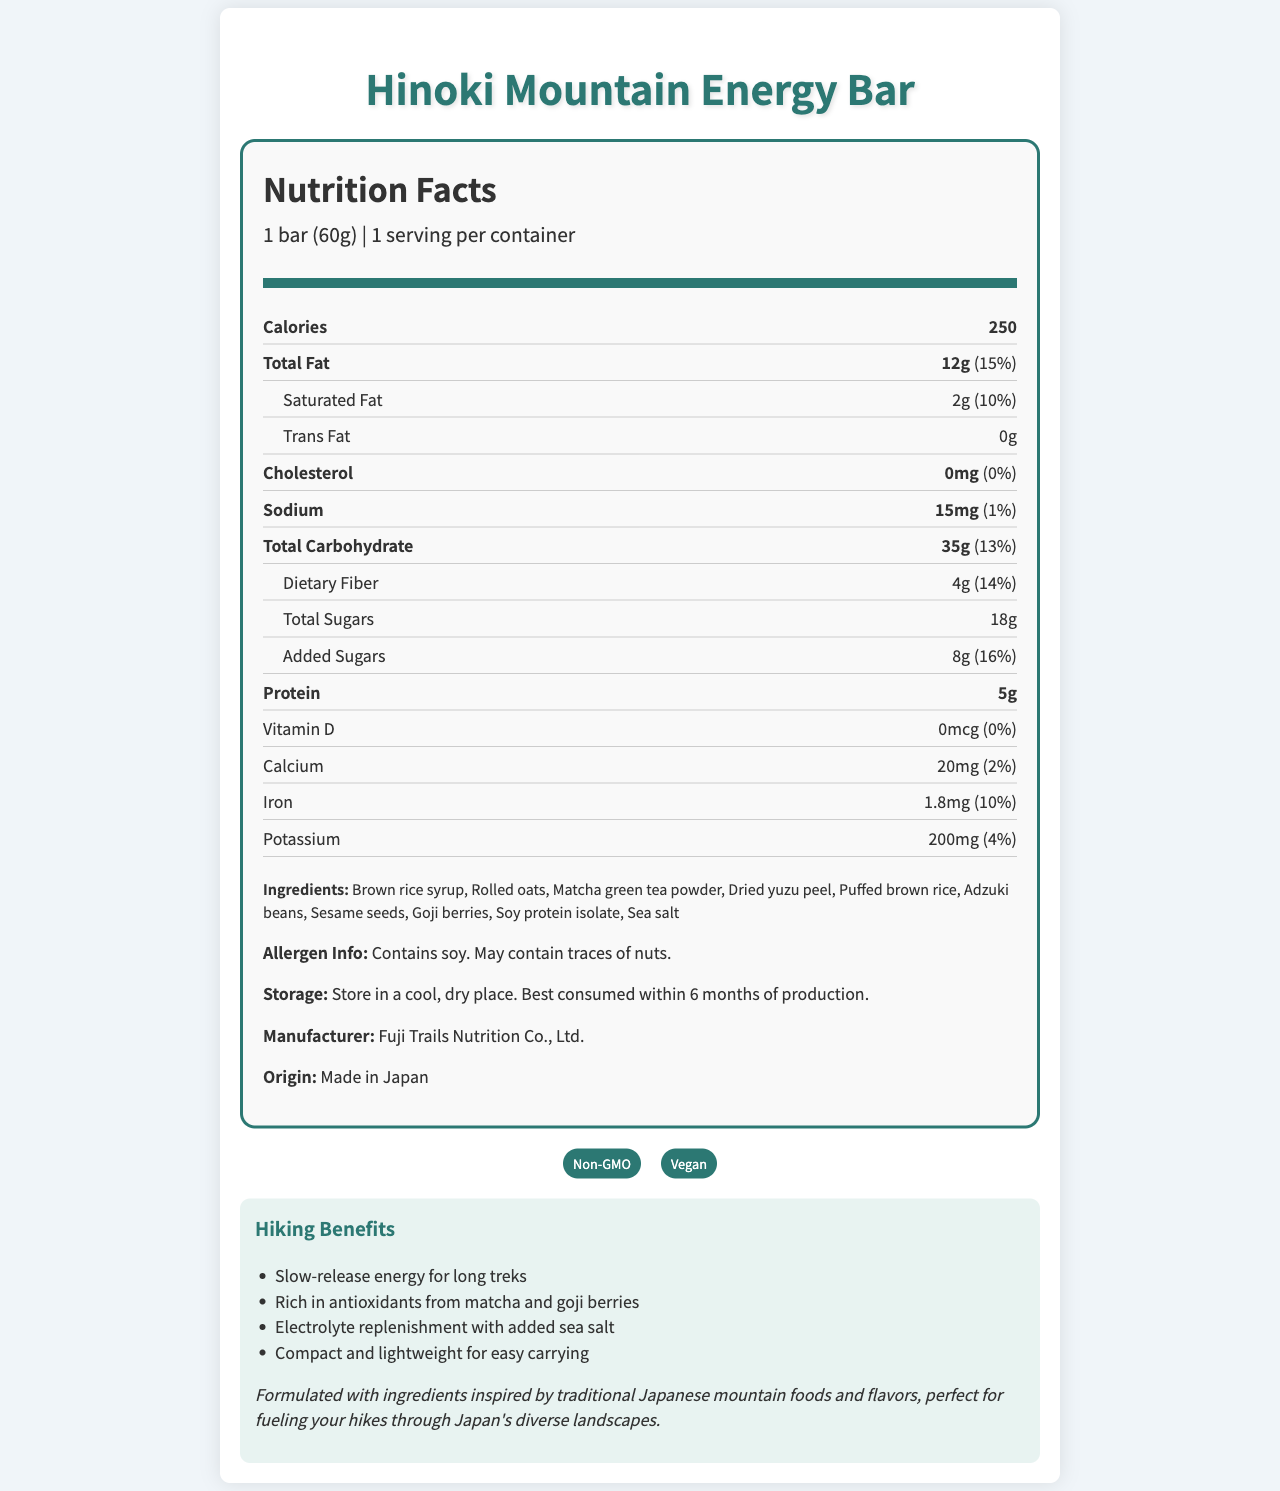what is the serving size for the Hinoki Mountain Energy Bar? The serving size is clearly stated at the top of the Nutrition Facts section as "1 bar (60g)".
Answer: 1 bar (60g) how many calories are in one serving? The document lists the calorie content right after the serving size information as 250 calories.
Answer: 250 what is the total fat content and its daily value percentage? The total fat content is mentioned as 12g with a daily value percentage of 15%.
Answer: 12g, 15% List two ingredients found in the Hinoki Mountain Energy Bar. Under the ingredients section, both "Brown rice syrup" and "Rolled oats" are listed.
Answer: Brown rice syrup, Rolled oats what is the total amount of sugars in the energy bar? The total sugars amount is specified under the sub-category "Total Sugars" as 18g.
Answer: 18g which nutrient has the highest percentage daily value? A. Saturated Fat B. Total Fat C. Dietary Fiber D. Added Sugars Added Sugars have a daily value of 16%, which is higher than the other listed options.
Answer: D what is the sodium content per serving? The sodium content is displayed under the main nutrients section as 15mg with a daily value of 1%.
Answer: 15mg is this energy bar suitable for someone avoiding soy? The allergen information clearly states that it contains soy.
Answer: No what are the benefits of this energy bar for hikers? The hiking benefits section lists multiple benefits, including slow-release energy, being rich in antioxidants from matcha and goji berries, electrolyte replenishment with sea salt, and being compact and lightweight.
Answer: Slow-release energy, Rich in antioxidants, Electrolyte replenishment, Compact and lightweight Is this energy bar Non-GMO certified? The certifications section includes a badge indicating that the product is Non-GMO.
Answer: Yes Which ingredient provides a source of protein in the energy bar? Among the ingredients listed, "Soy protein isolate" is the component that provides protein.
Answer: Soy protein isolate summarize the main idea of this document. The document details the nutritional information, ingredients, allergen info, storage instructions, certifications, and hiking benefits of the Hinoki Mountain Energy Bar, emphasizing its suitability for hikers and its traditional Japanese ingredient inspiration.
Answer: The Hinoki Mountain Energy Bar is a nutritious snack designed for hikers, offering 250 calories per bar with various nutrients and health benefits. It includes ingredients inspired by traditional Japanese foods and is marketed as a Non-GMO and Vegan product, suitable for providing slow-release energy and other benefits while hiking. how much iron does the bar contain as a percentage of the daily value? The document specifies that one bar contains 1.8mg of iron, which is 10% of the daily value.
Answer: 10% Does this energy bar contain any cholesterol? The nutritional information shows the cholesterol content as 0mg, with a daily value of 0%.
Answer: No Which fruit-based ingredients are present in the energy bar? A. Dried yuzu peel B. Cranberries C. Goji berries D. Puffed brown rice The ingredients section lists "Dried yuzu peel" and "Goji berries", whereas "Cranberries" and "Puffed brown rice" are not considered fruit-based.
Answer: A, C what traditional elements are in the ingredients inspired by Japanese mountain foods? The summary mentions that the energy bar is formulated with traditional Japanese ingredients, specifically referencing dried yuzu peel, matcha green tea powder, and adzuki beans.
Answer: Dried yuzu peel, Matcha green tea powder, Adzuki beans How many certifications does the Hinoki Mountain Energy Bar have and what are they? The document states that the bar has two certifications, which are Non-GMO and Vegan.
Answer: Two, Non-GMO and Vegan what is the amount of potassium in this energy bar? The potassium content is specified as 200mg with a daily value of 4%.
Answer: 200mg When is the best time to consume the energy bar after production? The storage instructions advise consuming the bar within 6 months of production.
Answer: Within 6 months What is the sugar source in the ingredients list? Among the listed ingredients, "Brown rice syrup" is the primary sugar source.
Answer: Brown rice syrup do we know the cost of the Hinoki Mountain Energy Bar from this document? The document does not provide any pricing or cost information about the energy bar.
Answer: Not enough information 